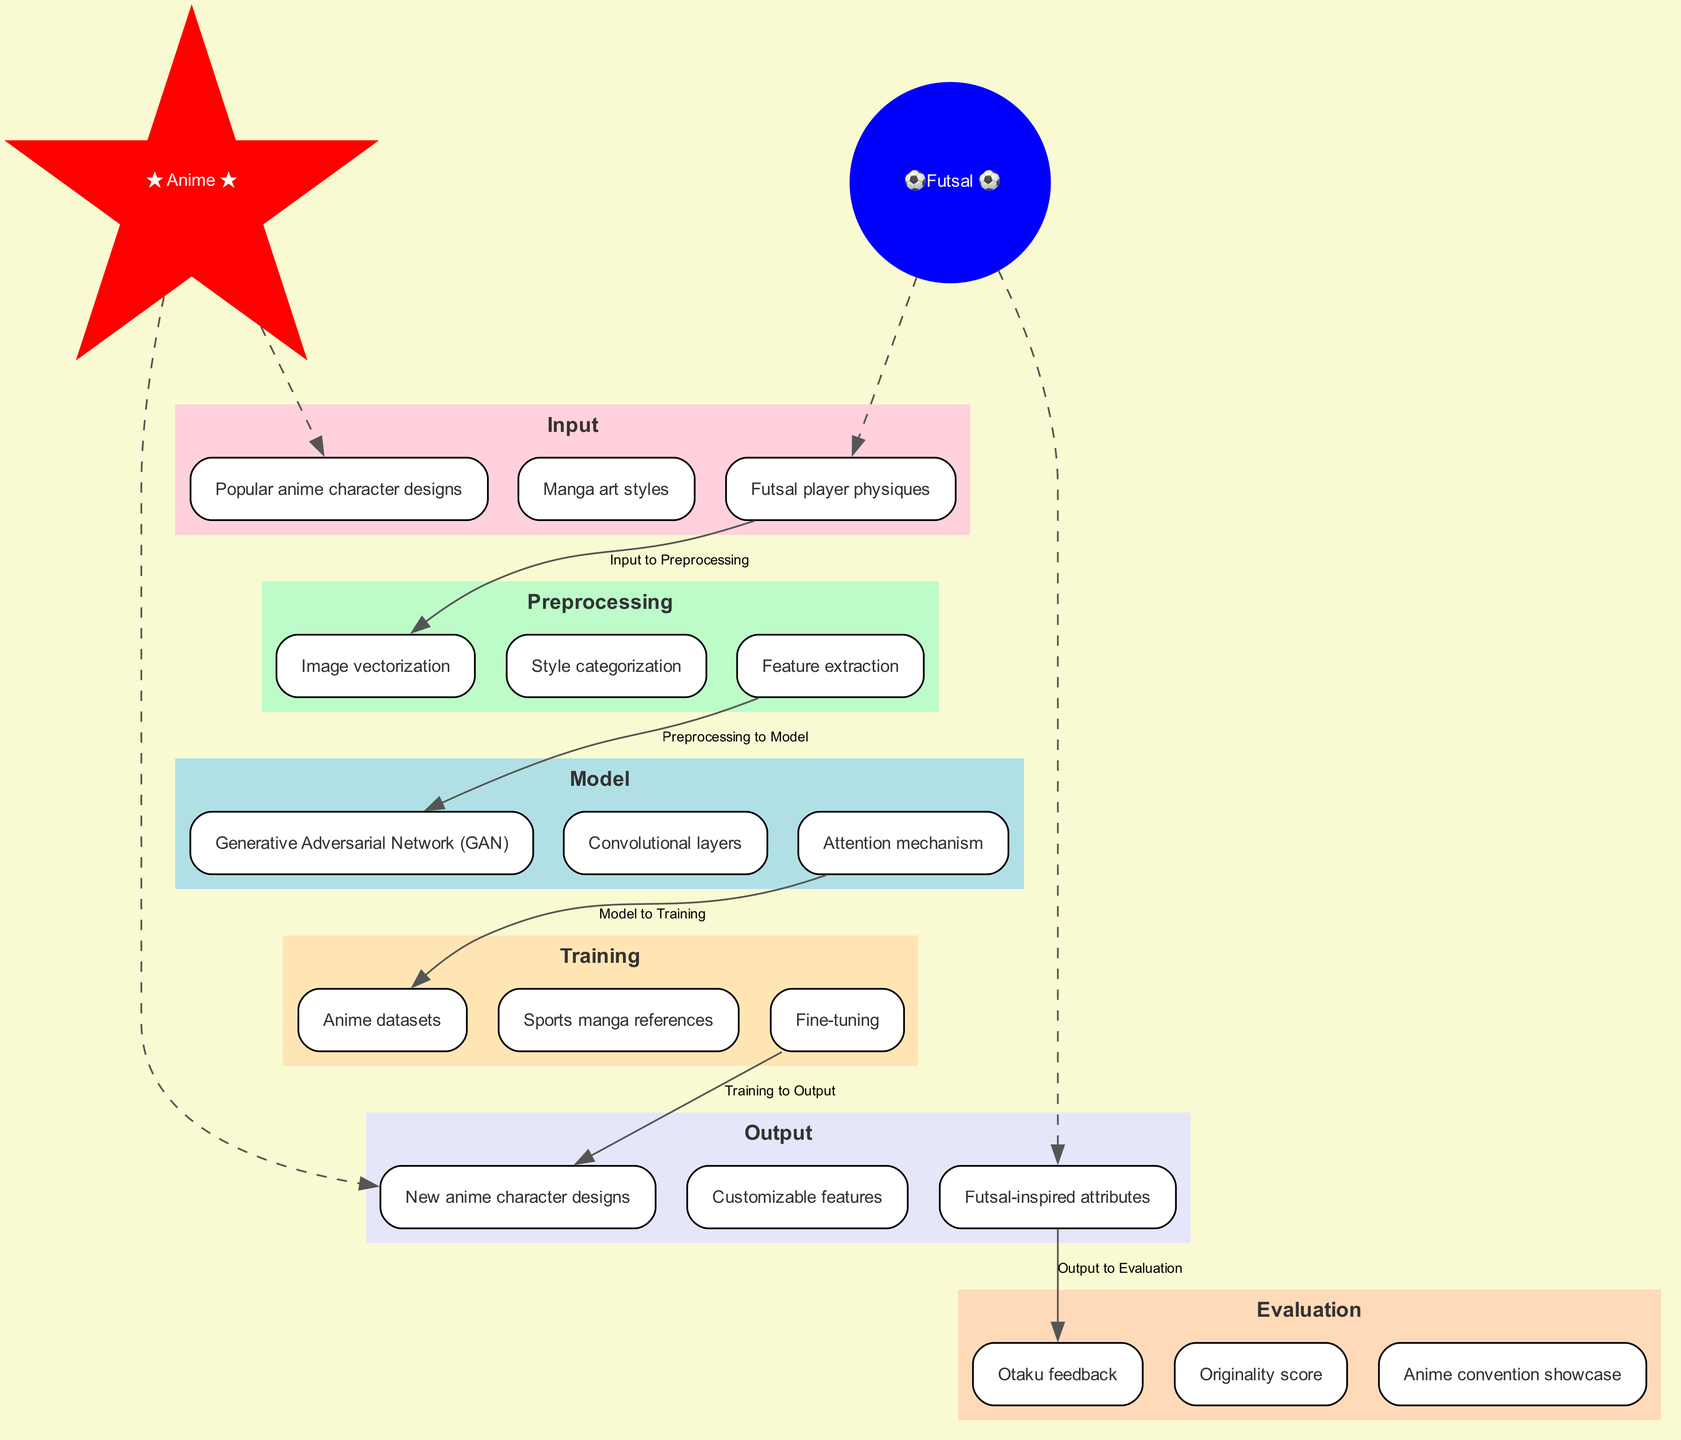What are the input components of the model? The input components include "Popular anime character designs," "Manga art styles," and "Futsal player physiques" as shown in the Input stage of the diagram.
Answer: Popular anime character designs, Manga art styles, Futsal player physiques What is the model architecture used in this diagram? The model architecture is a "Generative Adversarial Network (GAN)" that also incorporates "Convolutional layers" and an "Attention mechanism," all listed in the Model stage.
Answer: Generative Adversarial Network (GAN), Convolutional layers, Attention mechanism How many training data sources are identified? Three training data sources are mentioned in the Training stage: "Anime datasets," "Sports manga references," and "Fine-tuning," indicating a total of three sources.
Answer: 3 What is the final output of the model? The final output of the model consists of "New anime character designs," "Customizable features," and "Futsal-inspired attributes" as denoted in the Output stage of the diagram.
Answer: New anime character designs, Customizable features, Futsal-inspired attributes Which component is directly connected to the preprocessing stage? The preprocessing stage is directly connected to the input component "Popular anime character designs," indicating the primary source feeding into that stage.
Answer: Popular anime character designs What type of feedback is used in the evaluation phase? The evaluation phase uses "Otaku feedback" to measure how well the generated designs resonate with fans, as shown in the Evaluation stage.
Answer: Otaku feedback Explain the connection between the input and output concerning anime attributes. The output "New anime character designs" and "Futsal-inspired attributes" are both derived from the input component "Popular anime character designs." The flow suggests that popular designs inform the new character creations while incorporating futsal elements.
Answer: Popular anime character designs to New anime character designs, Futsal-inspired attributes How does the model utilize sport references in training? The Training stage specifies "Sports manga references," which indicates that the model integrates styles and features from sports manga to enhance its training, particularly for generating futsal characteristics.
Answer: Sports manga references Identify the special nodes introduced in the diagram and their themes. The diagram introduces special nodes labeled "★ Anime ★" and "⚽ Futsal ⚽," signifying themes related to anime and futsal, which connect to specific inputs and outputs involving those elements.
Answer: ★ Anime ★, ⚽ Futsal ⚽ 